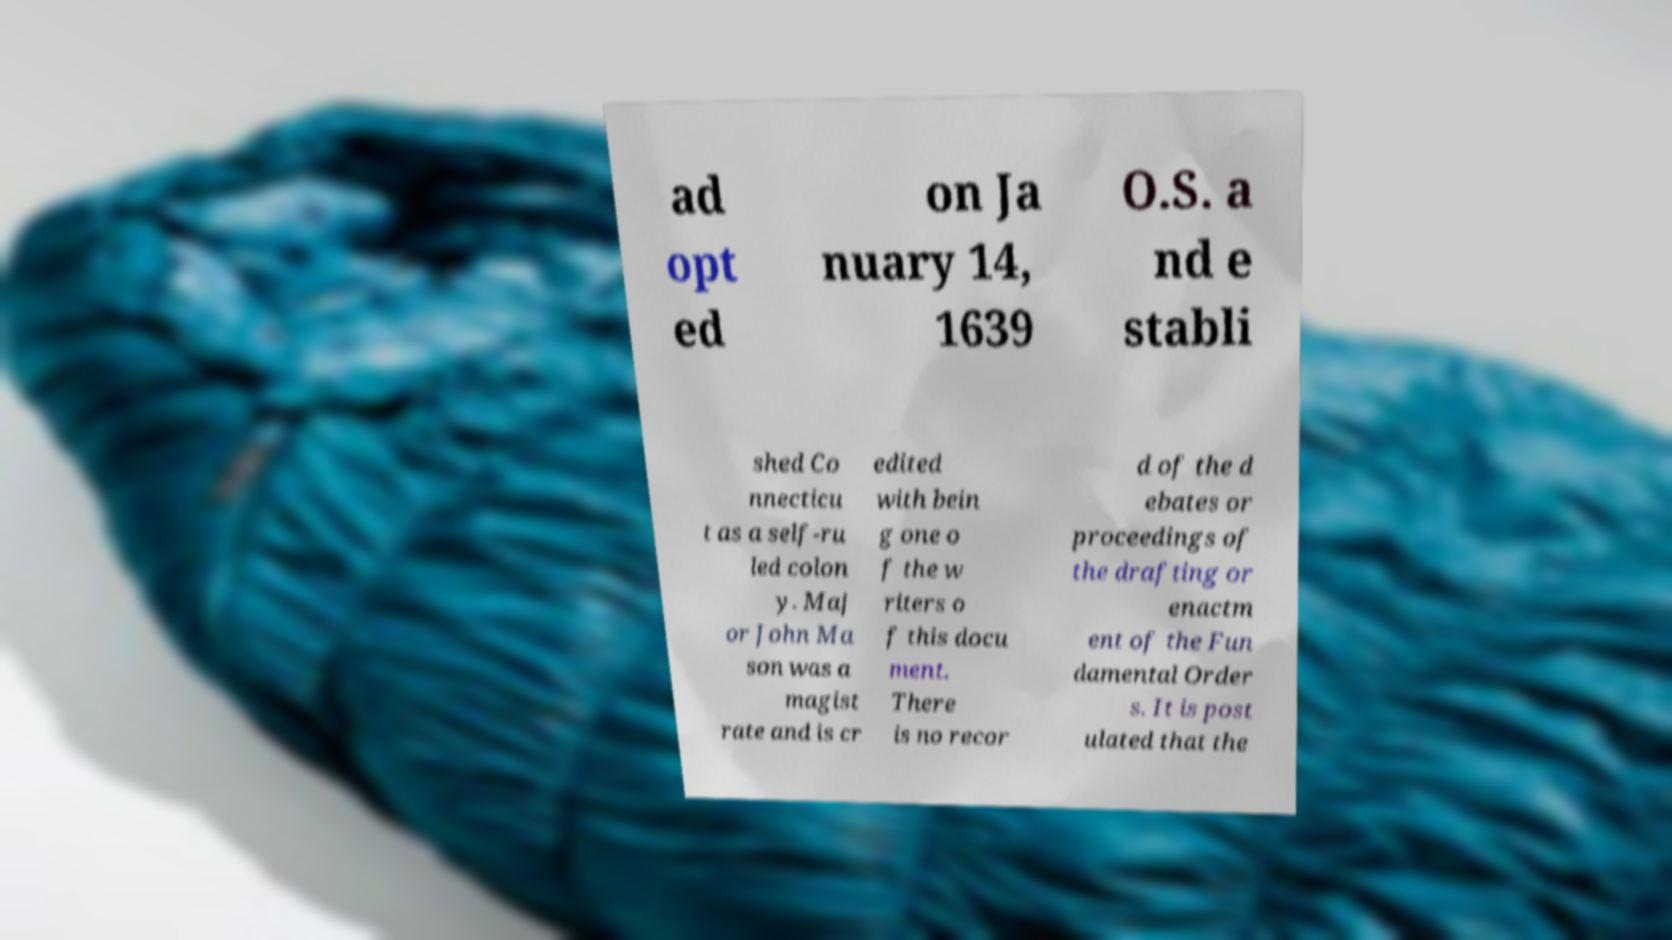Can you accurately transcribe the text from the provided image for me? ad opt ed on Ja nuary 14, 1639 O.S. a nd e stabli shed Co nnecticu t as a self-ru led colon y. Maj or John Ma son was a magist rate and is cr edited with bein g one o f the w riters o f this docu ment. There is no recor d of the d ebates or proceedings of the drafting or enactm ent of the Fun damental Order s. It is post ulated that the 